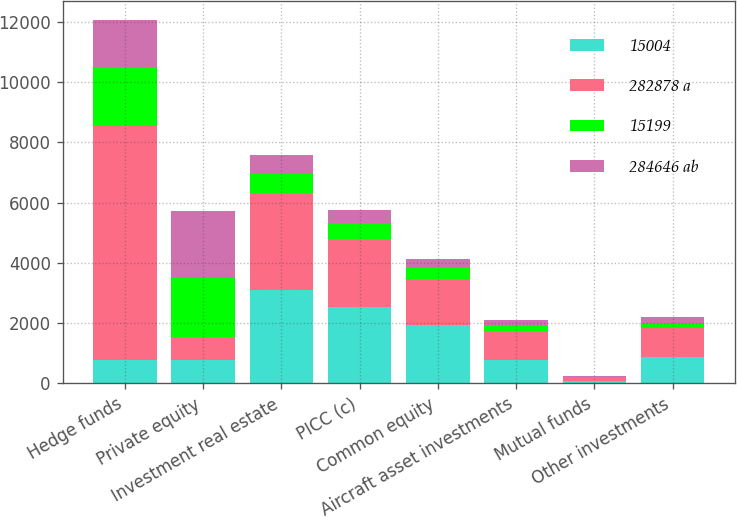<chart> <loc_0><loc_0><loc_500><loc_500><stacked_bar_chart><ecel><fcel>Hedge funds<fcel>Private equity<fcel>Investment real estate<fcel>PICC (c)<fcel>Common equity<fcel>Aircraft asset investments<fcel>Mutual funds<fcel>Other investments<nl><fcel>15004<fcel>763<fcel>763<fcel>3113<fcel>2536<fcel>1927<fcel>763<fcel>85<fcel>872<nl><fcel>282878 a<fcel>7767<fcel>763<fcel>3195<fcel>2262<fcel>1526<fcel>984<fcel>128<fcel>963<nl><fcel>15199<fcel>1980<fcel>1962<fcel>623<fcel>507<fcel>385<fcel>153<fcel>17<fcel>174<nl><fcel>284646 ab<fcel>1553<fcel>2245<fcel>639<fcel>452<fcel>305<fcel>197<fcel>26<fcel>193<nl></chart> 